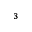<formula> <loc_0><loc_0><loc_500><loc_500>^ { 3 }</formula> 